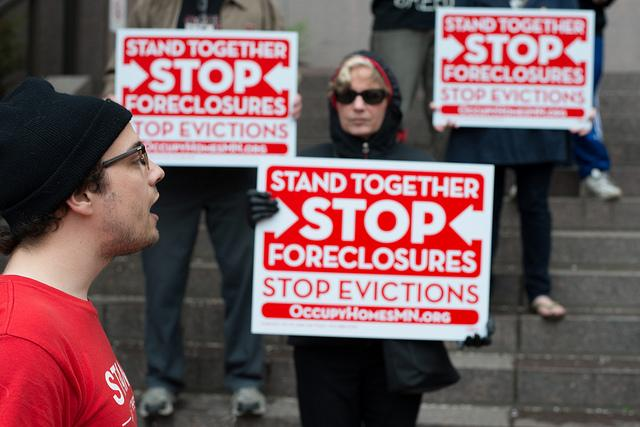What might the item on the woman's face be used to shield from?

Choices:
A) punches
B) sun
C) rain
D) bees sun 